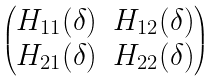<formula> <loc_0><loc_0><loc_500><loc_500>\begin{pmatrix} H _ { 1 1 } ( \delta ) & H _ { 1 2 } ( \delta ) \\ H _ { 2 1 } ( \delta ) & H _ { 2 2 } ( \delta ) \end{pmatrix}</formula> 